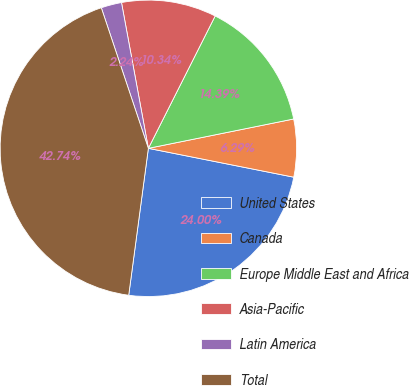Convert chart to OTSL. <chart><loc_0><loc_0><loc_500><loc_500><pie_chart><fcel>United States<fcel>Canada<fcel>Europe Middle East and Africa<fcel>Asia-Pacific<fcel>Latin America<fcel>Total<nl><fcel>24.0%<fcel>6.29%<fcel>14.39%<fcel>10.34%<fcel>2.24%<fcel>42.74%<nl></chart> 